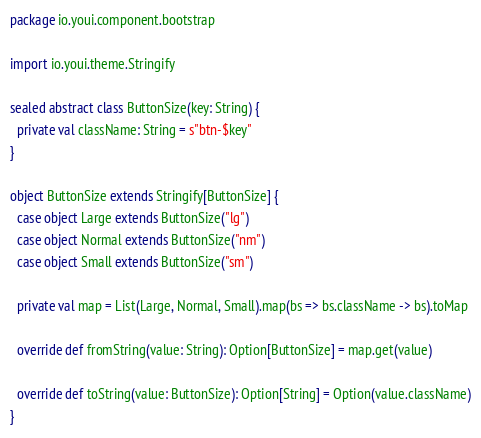Convert code to text. <code><loc_0><loc_0><loc_500><loc_500><_Scala_>package io.youi.component.bootstrap

import io.youi.theme.Stringify

sealed abstract class ButtonSize(key: String) {
  private val className: String = s"btn-$key"
}

object ButtonSize extends Stringify[ButtonSize] {
  case object Large extends ButtonSize("lg")
  case object Normal extends ButtonSize("nm")
  case object Small extends ButtonSize("sm")

  private val map = List(Large, Normal, Small).map(bs => bs.className -> bs).toMap

  override def fromString(value: String): Option[ButtonSize] = map.get(value)

  override def toString(value: ButtonSize): Option[String] = Option(value.className)
}</code> 